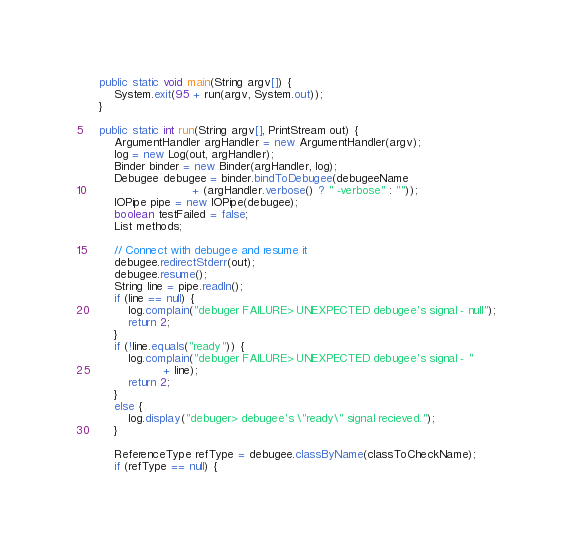Convert code to text. <code><loc_0><loc_0><loc_500><loc_500><_Java_>
    public static void main(String argv[]) {
        System.exit(95 + run(argv, System.out));
    }

    public static int run(String argv[], PrintStream out) {
        ArgumentHandler argHandler = new ArgumentHandler(argv);
        log = new Log(out, argHandler);
        Binder binder = new Binder(argHandler, log);
        Debugee debugee = binder.bindToDebugee(debugeeName
                              + (argHandler.verbose() ? " -verbose" : ""));
        IOPipe pipe = new IOPipe(debugee);
        boolean testFailed = false;
        List methods;

        // Connect with debugee and resume it
        debugee.redirectStderr(out);
        debugee.resume();
        String line = pipe.readln();
        if (line == null) {
            log.complain("debuger FAILURE> UNEXPECTED debugee's signal - null");
            return 2;
        }
        if (!line.equals("ready")) {
            log.complain("debuger FAILURE> UNEXPECTED debugee's signal - "
                      + line);
            return 2;
        }
        else {
            log.display("debuger> debugee's \"ready\" signal recieved.");
        }

        ReferenceType refType = debugee.classByName(classToCheckName);
        if (refType == null) {</code> 